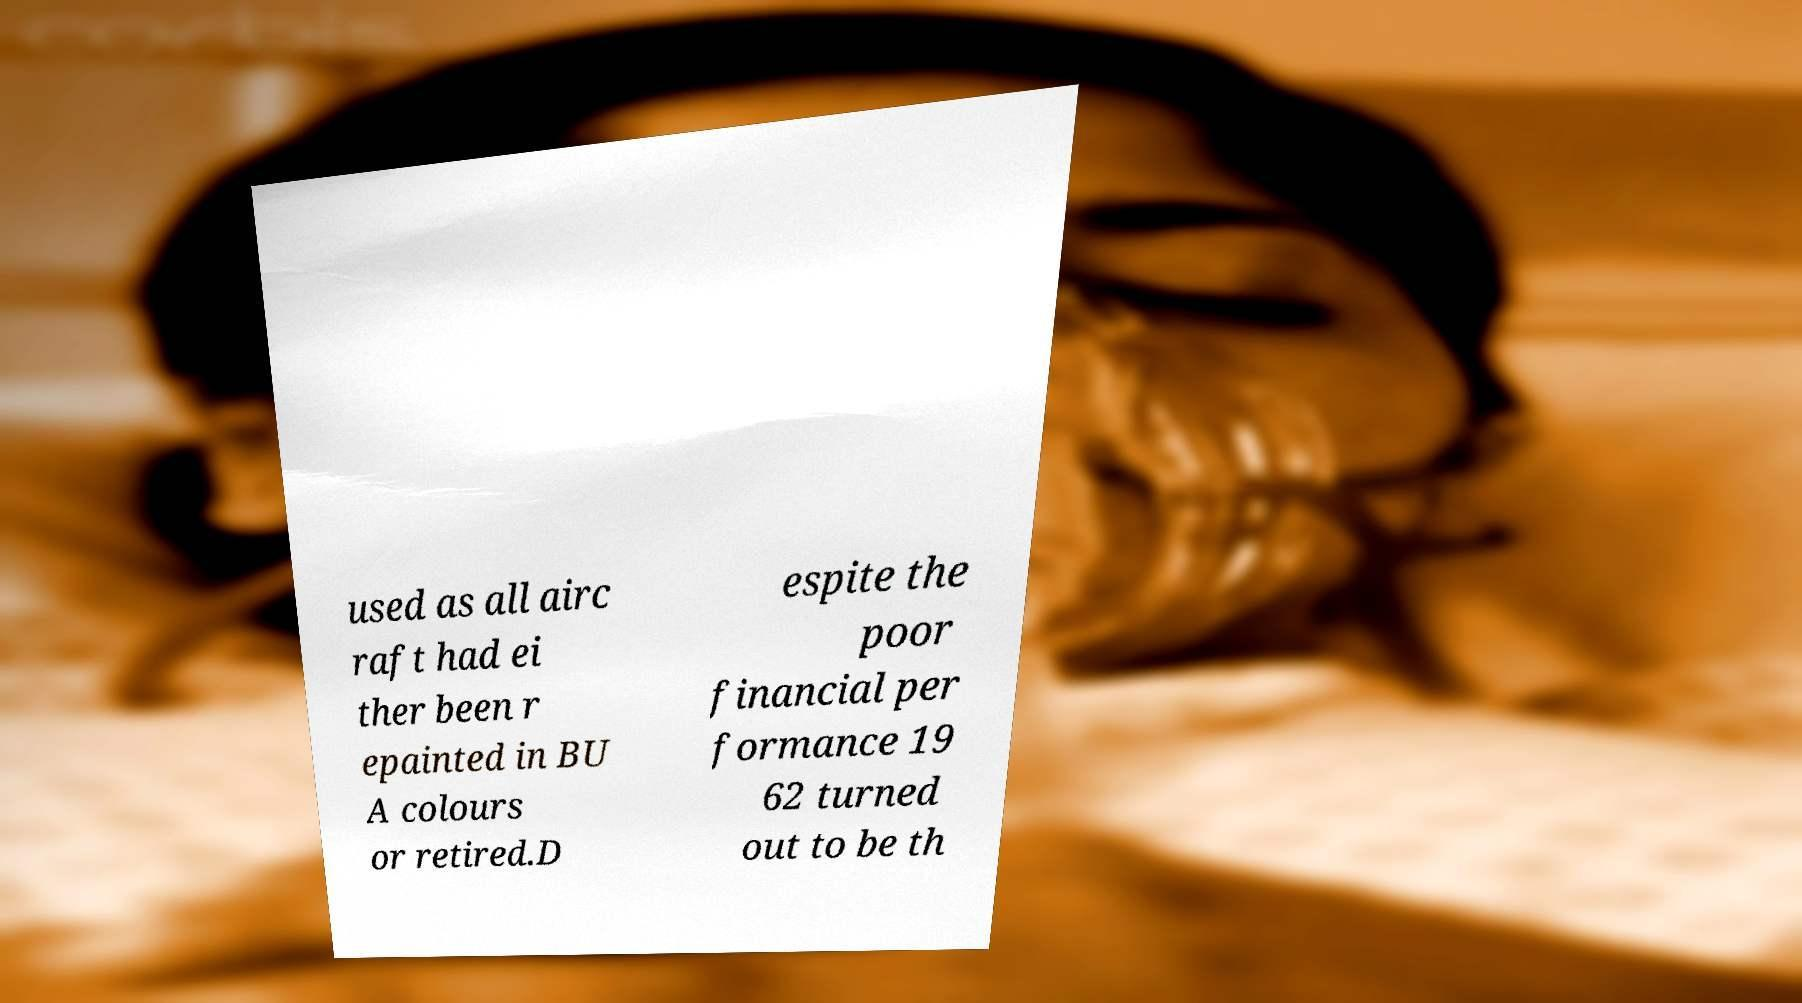What messages or text are displayed in this image? I need them in a readable, typed format. used as all airc raft had ei ther been r epainted in BU A colours or retired.D espite the poor financial per formance 19 62 turned out to be th 